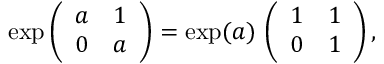<formula> <loc_0><loc_0><loc_500><loc_500>\exp \left ( \begin{array} { c c } { a } & { 1 } \\ { 0 } & { a } \end{array} \right ) = \exp ( a ) \, \left ( \begin{array} { c c } { 1 } & { 1 } \\ { 0 } & { 1 } \end{array} \right ) ,</formula> 